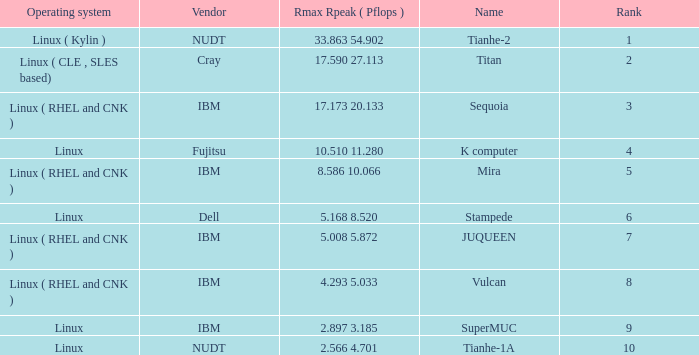What is the rank of Rmax Rpeak ( Pflops ) of 17.173 20.133? 3.0. 